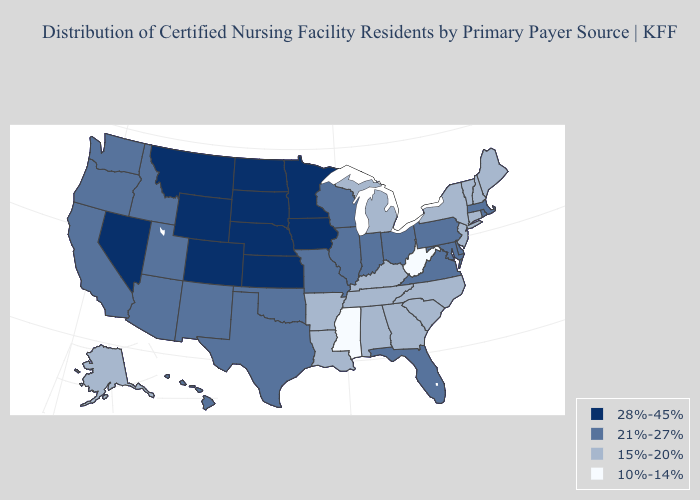Name the states that have a value in the range 10%-14%?
Be succinct. Mississippi, West Virginia. Does Louisiana have a higher value than Oklahoma?
Keep it brief. No. What is the value of Iowa?
Write a very short answer. 28%-45%. What is the value of Nebraska?
Be succinct. 28%-45%. Does Kansas have the highest value in the USA?
Short answer required. Yes. What is the highest value in the USA?
Write a very short answer. 28%-45%. Does New Mexico have a lower value than Wisconsin?
Quick response, please. No. What is the value of Massachusetts?
Short answer required. 21%-27%. What is the value of Idaho?
Be succinct. 21%-27%. Name the states that have a value in the range 21%-27%?
Concise answer only. Arizona, California, Delaware, Florida, Hawaii, Idaho, Illinois, Indiana, Maryland, Massachusetts, Missouri, New Mexico, Ohio, Oklahoma, Oregon, Pennsylvania, Rhode Island, Texas, Utah, Virginia, Washington, Wisconsin. Does the map have missing data?
Be succinct. No. Which states hav the highest value in the South?
Answer briefly. Delaware, Florida, Maryland, Oklahoma, Texas, Virginia. Which states hav the highest value in the South?
Give a very brief answer. Delaware, Florida, Maryland, Oklahoma, Texas, Virginia. Name the states that have a value in the range 28%-45%?
Keep it brief. Colorado, Iowa, Kansas, Minnesota, Montana, Nebraska, Nevada, North Dakota, South Dakota, Wyoming. 